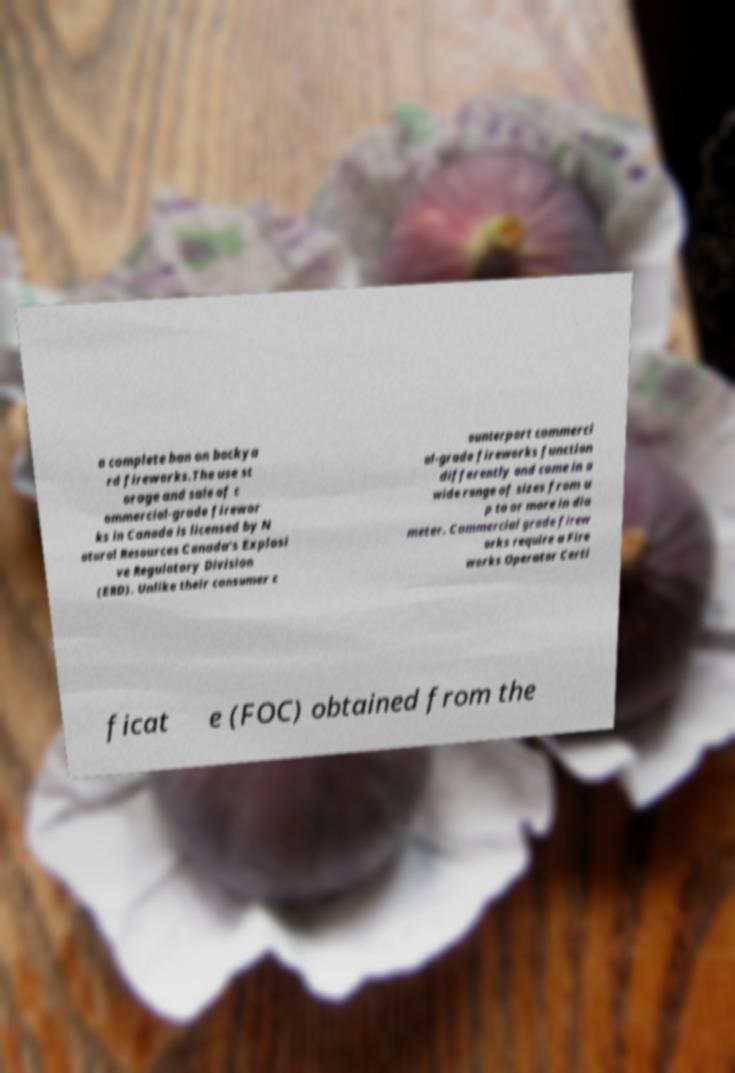Can you read and provide the text displayed in the image?This photo seems to have some interesting text. Can you extract and type it out for me? a complete ban on backya rd fireworks.The use st orage and sale of c ommercial-grade firewor ks in Canada is licensed by N atural Resources Canada's Explosi ve Regulatory Division (ERD). Unlike their consumer c ounterpart commerci al-grade fireworks function differently and come in a wide range of sizes from u p to or more in dia meter. Commercial grade firew orks require a Fire works Operator Certi ficat e (FOC) obtained from the 